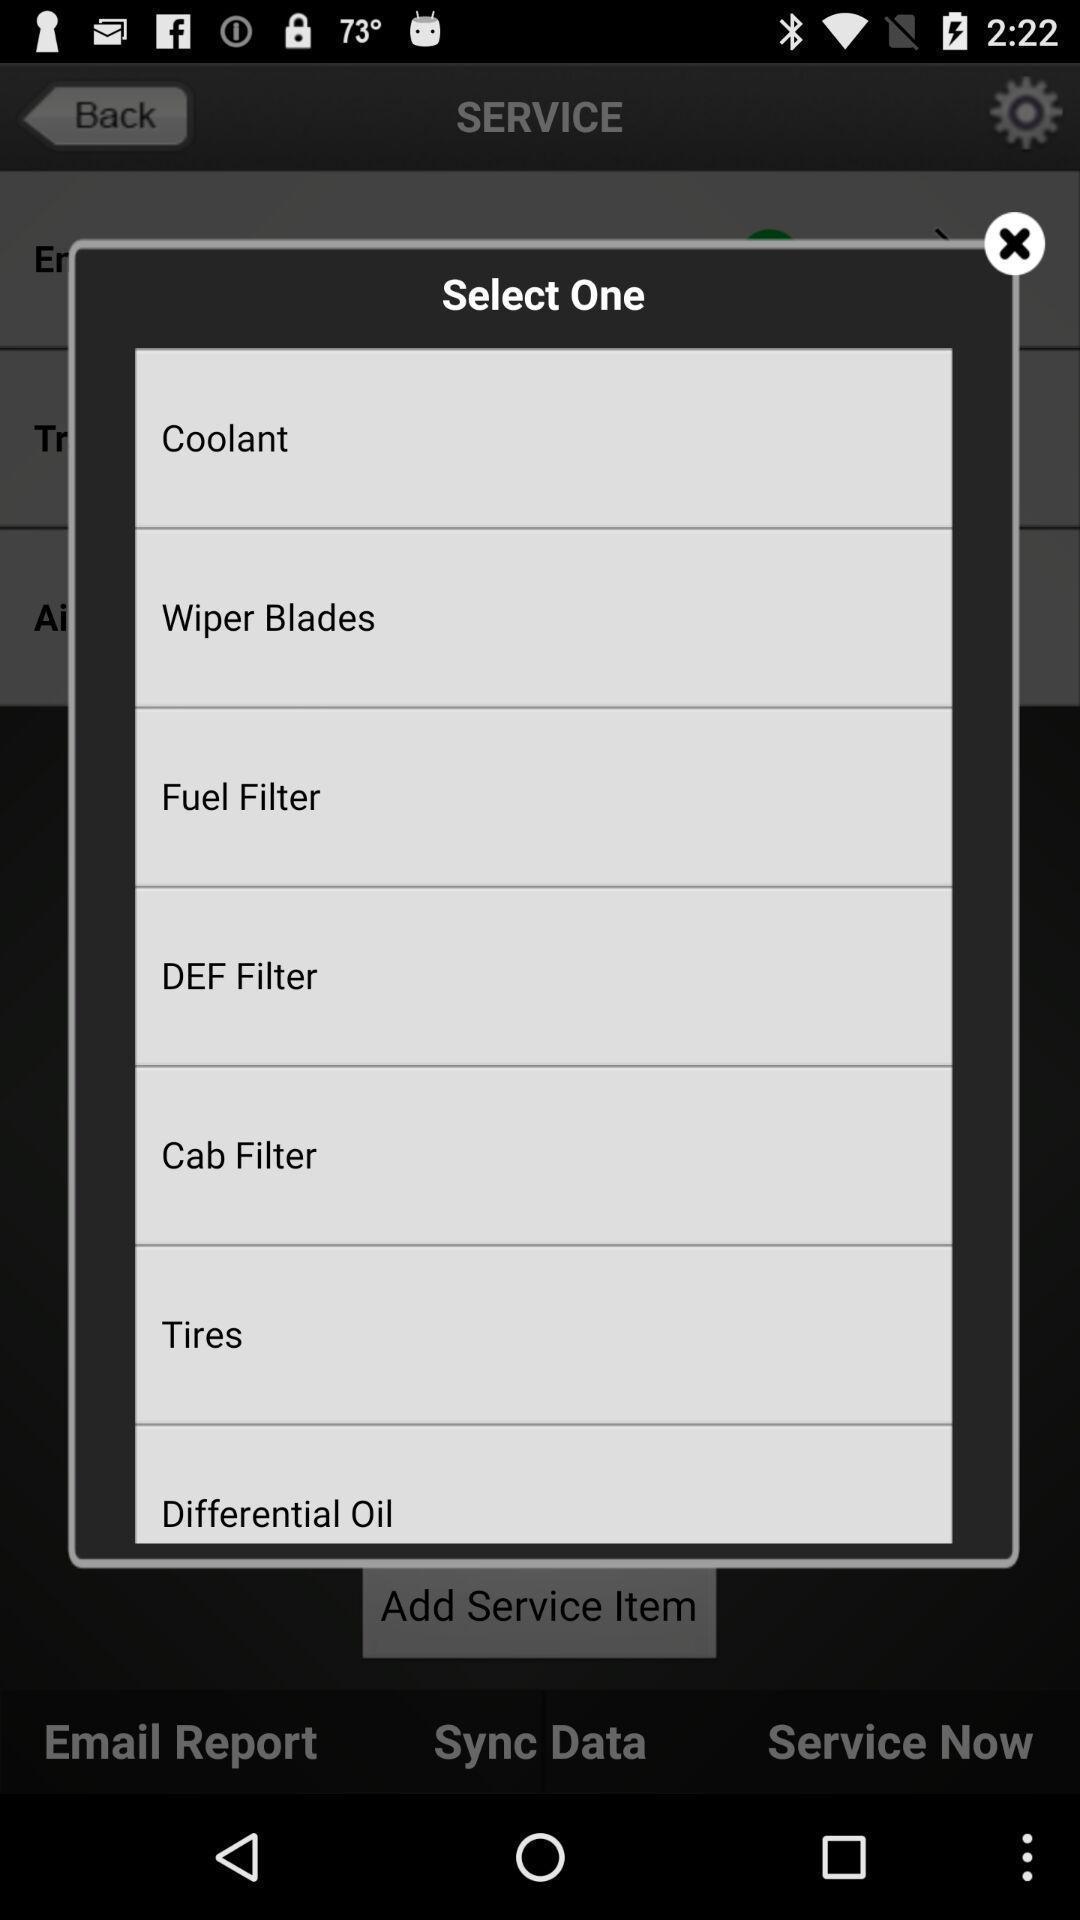Tell me what you see in this picture. Pp up asking to select one from the list. 